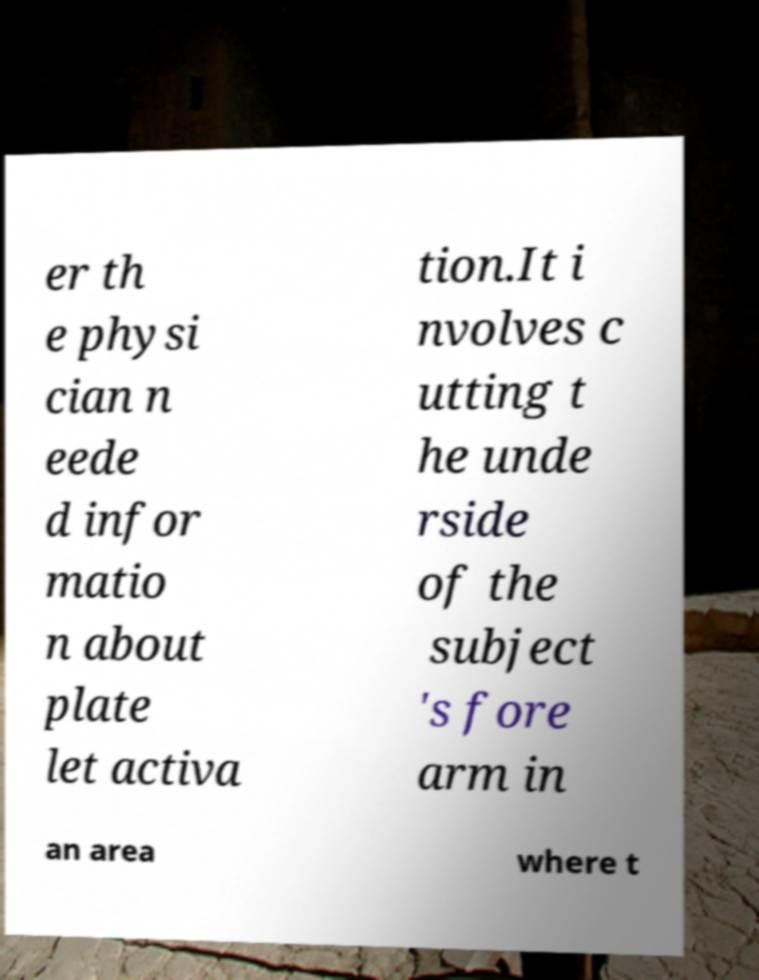Could you assist in decoding the text presented in this image and type it out clearly? er th e physi cian n eede d infor matio n about plate let activa tion.It i nvolves c utting t he unde rside of the subject 's fore arm in an area where t 